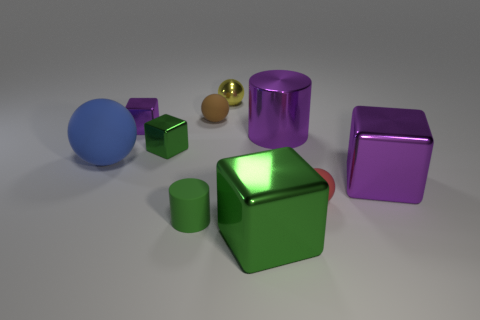Subtract 1 spheres. How many spheres are left? 3 Subtract all balls. How many objects are left? 6 Subtract 0 brown cylinders. How many objects are left? 10 Subtract all yellow metallic balls. Subtract all yellow things. How many objects are left? 8 Add 3 yellow metallic spheres. How many yellow metallic spheres are left? 4 Add 1 small purple blocks. How many small purple blocks exist? 2 